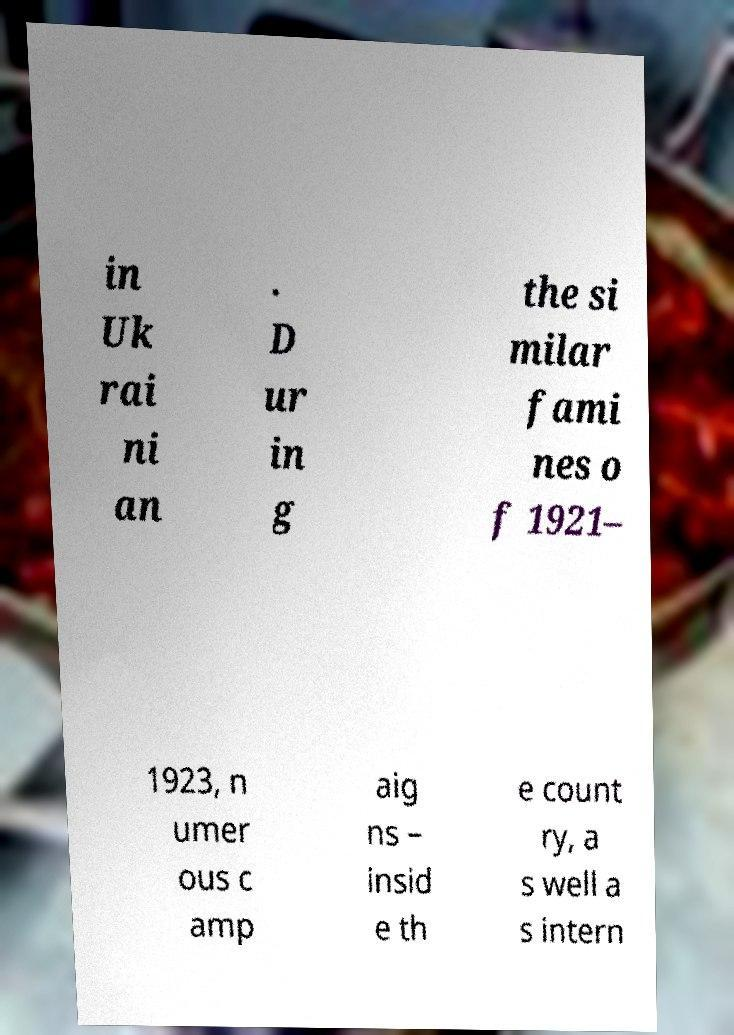Please identify and transcribe the text found in this image. in Uk rai ni an . D ur in g the si milar fami nes o f 1921– 1923, n umer ous c amp aig ns – insid e th e count ry, a s well a s intern 